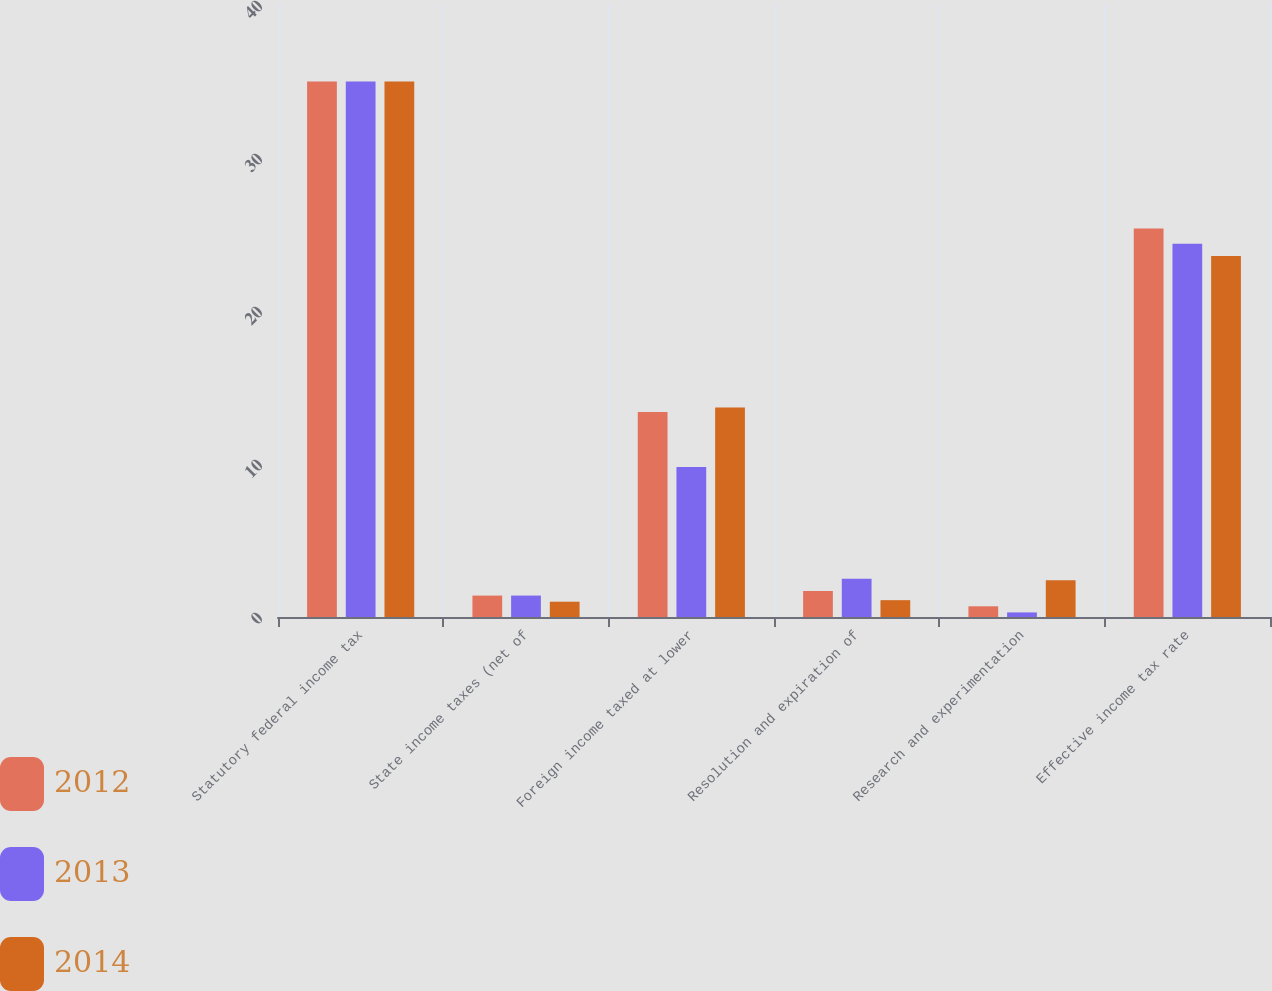<chart> <loc_0><loc_0><loc_500><loc_500><stacked_bar_chart><ecel><fcel>Statutory federal income tax<fcel>State income taxes (net of<fcel>Foreign income taxed at lower<fcel>Resolution and expiration of<fcel>Research and experimentation<fcel>Effective income tax rate<nl><fcel>2012<fcel>35<fcel>1.4<fcel>13.4<fcel>1.7<fcel>0.7<fcel>25.4<nl><fcel>2013<fcel>35<fcel>1.4<fcel>9.8<fcel>2.5<fcel>0.3<fcel>24.4<nl><fcel>2014<fcel>35<fcel>1<fcel>13.7<fcel>1.1<fcel>2.4<fcel>23.6<nl></chart> 